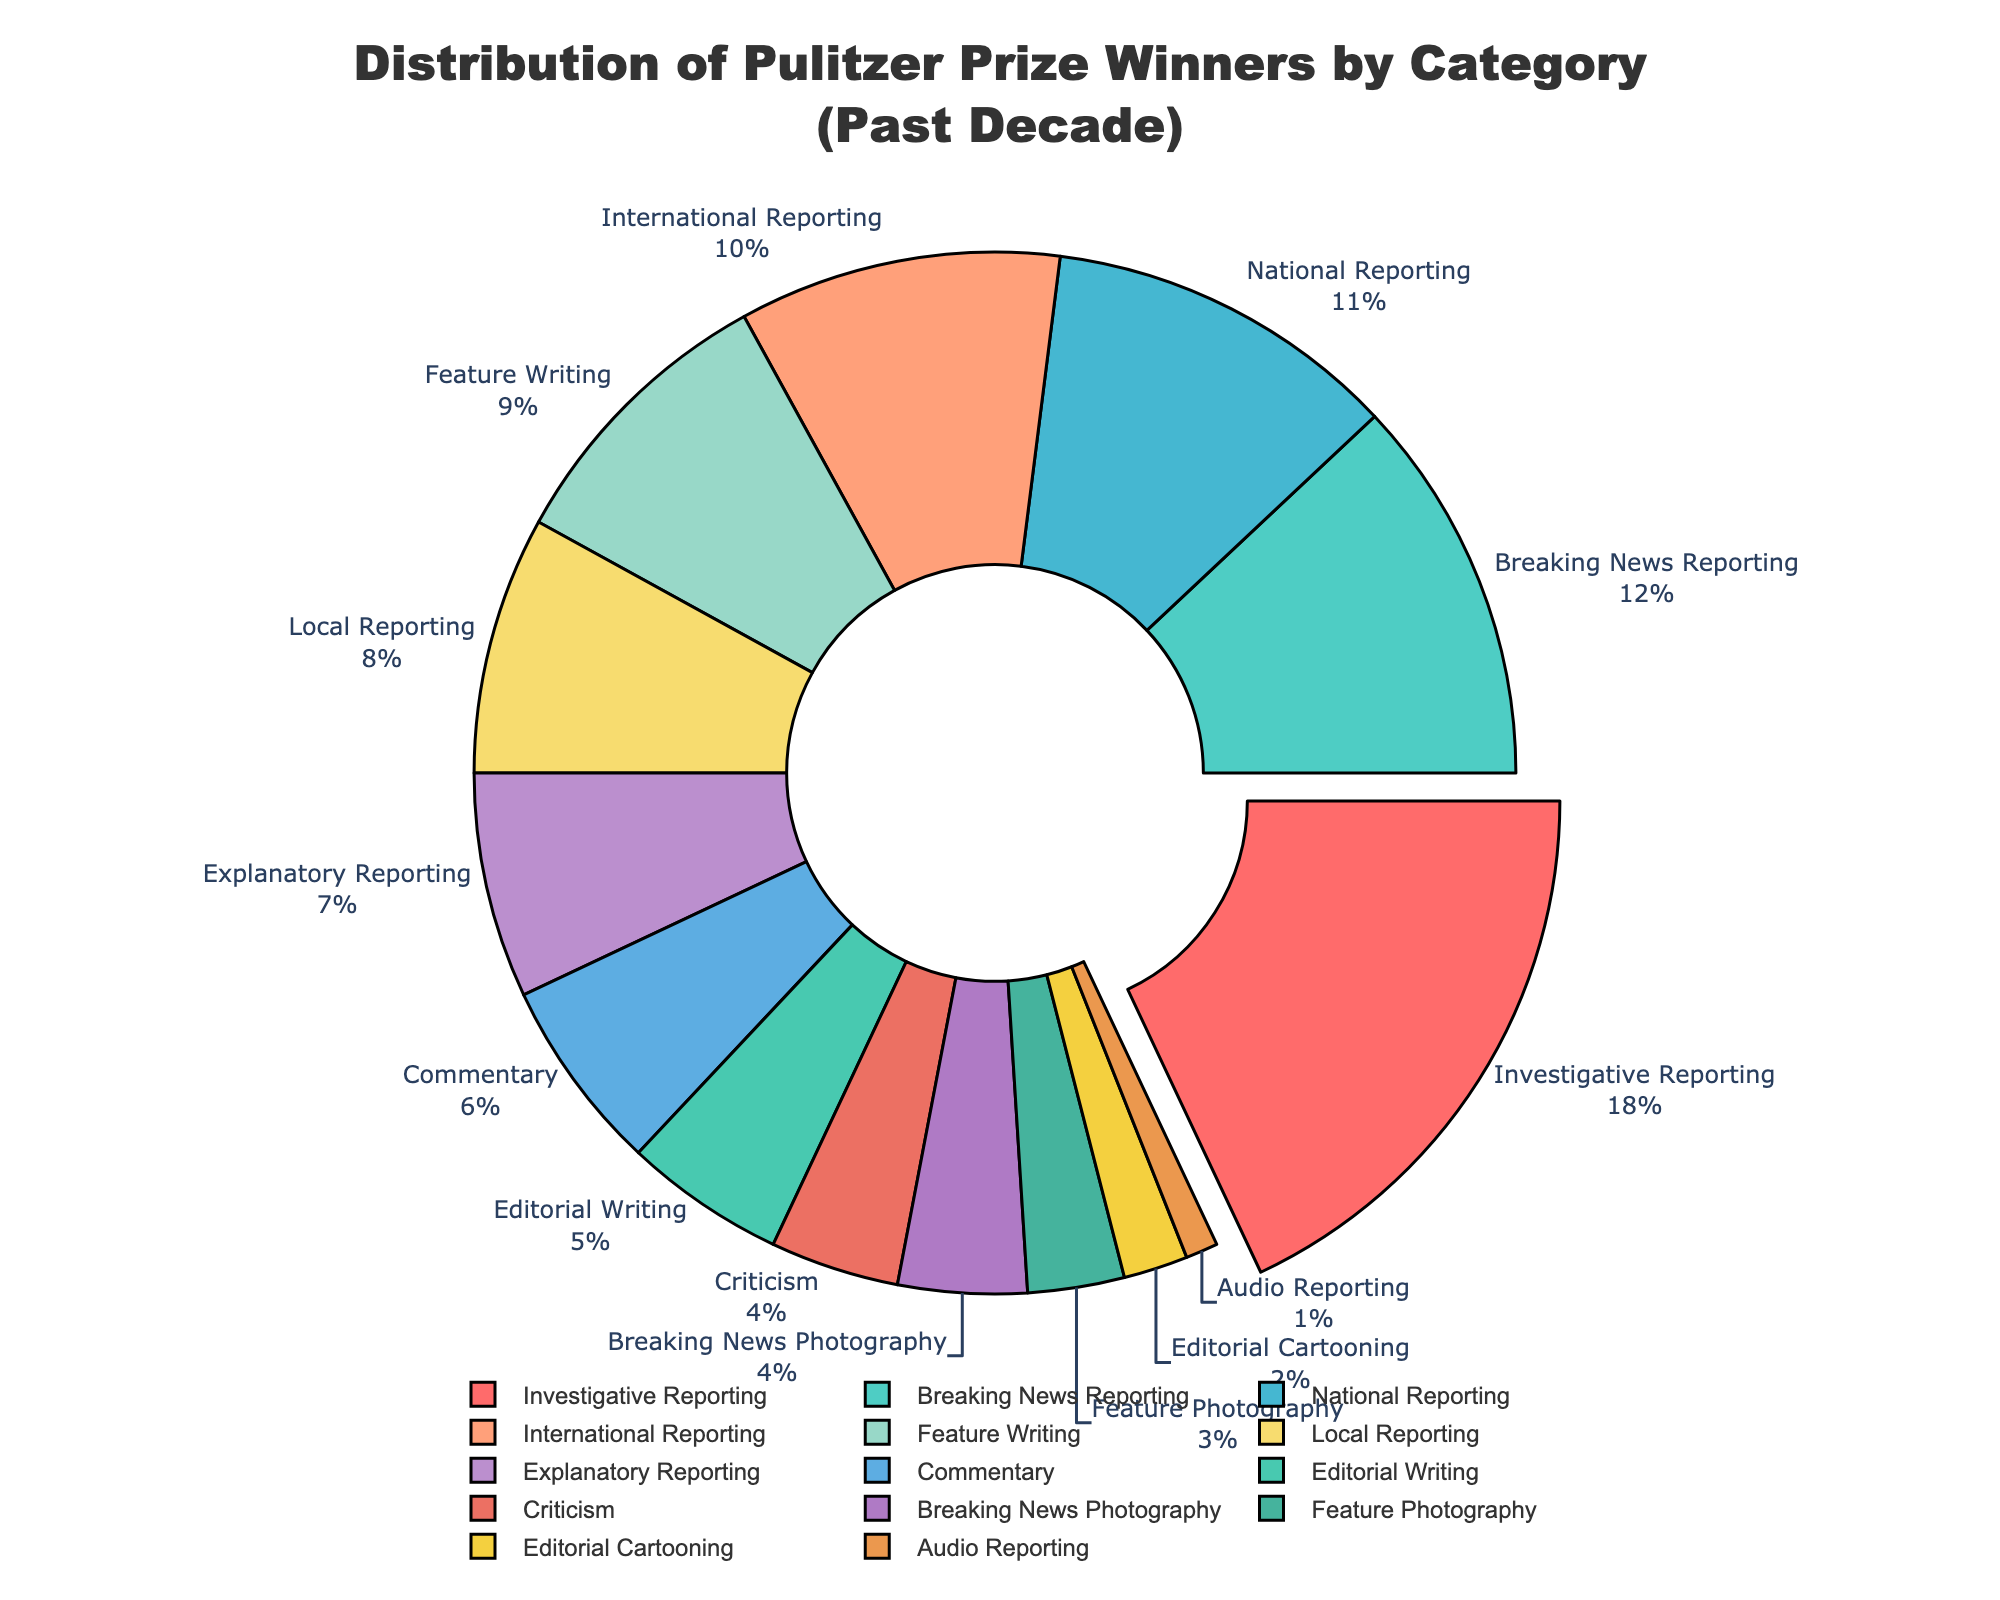What is the percentage of Pulitzer Prize winners in Investigative Reporting? In the pie chart, Investigative Reporting has the largest segment. According to the chart, Investigative Reporting constitutes approximately 22% of the winners over the past decade.
Answer: 22% Which category has the second largest share of winners? The pie chart shows that Breaking News Reporting has the second largest segment after Investigative Reporting.
Answer: Breaking News Reporting How many categories have less than 5% of the total Pulitzer Prize winners? Evaluating the pie chart, we can see that Commentary, Editorial Writing, Criticism, Breaking News Photography, Feature Photography, Editorial Cartooning, and Audio Reporting each occupy less than 5%. There are seven categories in total.
Answer: 7 What is the combined percentage of winners in Breaking News Photography and Feature Photography? Breaking News Photography and Feature Photography have shares around 5% each, combining to approximately 9% in total.
Answer: 9% Does National Reporting have a higher or lower percentage of winners compared to International Reporting? Observing the pie chart, National Reporting has an 11% share while International Reporting has a 10% share. Therefore, National Reporting has a higher percentage.
Answer: Higher How much larger is the share of the largest category compared to the smallest category? The largest category, Investigative Reporting, has a share of approximately 22%, and the smallest category, Audio Reporting, has about 1%. The difference between them is 21%.
Answer: 21% What is the main color used for Local Reporting in the pie chart? The segment representing Local Reporting in the pie chart is shaded with a greenish color.
Answer: Green If you combine the winners in National Reporting, International Reporting, and Local Reporting, what is their combined percentage? Adding their respective percentages (11% for National, 10% for International, and 8% for Local) gives a combined total of approximately 29%.
Answer: 29% Which category has a slightly higher number of winners: Feature Writing or Explanatory Reporting? Feature Writing is observed to have a slightly larger segment than Explanatory Reporting, with 9% and 7% respectively.
Answer: Feature Writing How does the color of Editorial Writing compare to that of Investigative Reporting? The segment for Editorial Writing is a shade of purple, whereas Investigative Reporting is predominantly red.
Answer: Purple vs. Red 